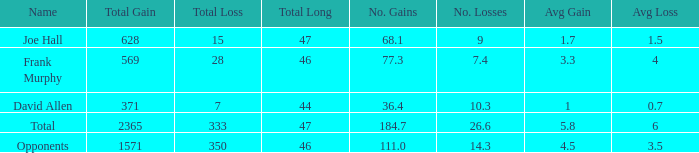What is the average gain per game for instances where the gain is less than 1571 and the longest gain is less than 46? 1.0. 